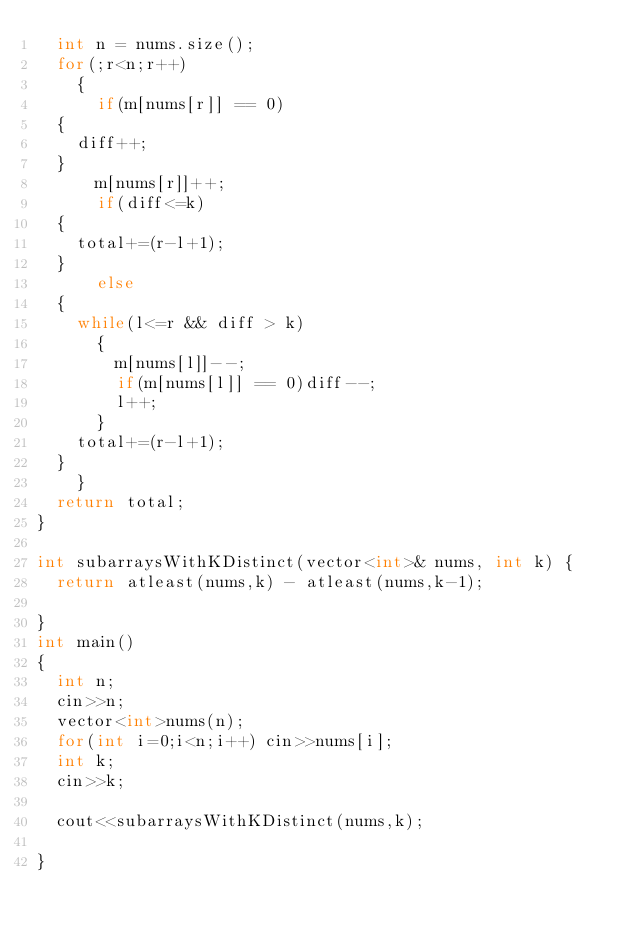<code> <loc_0><loc_0><loc_500><loc_500><_C++_>  int n = nums.size();
  for(;r<n;r++)
    {
      if(m[nums[r]] == 0)
	{
	  diff++;
	}
      m[nums[r]]++;
      if(diff<=k) 
	{
	  total+=(r-l+1);
	}
      else
	{
	  while(l<=r && diff > k)
	    {
	      m[nums[l]]--;
	      if(m[nums[l]] == 0)diff--;
	      l++;
	    }
	  total+=(r-l+1);
	}
    }
  return total;
}

int subarraysWithKDistinct(vector<int>& nums, int k) {
  return atleast(nums,k) - atleast(nums,k-1);
        
}
int main()
{
  int n;
  cin>>n;
  vector<int>nums(n);
  for(int i=0;i<n;i++) cin>>nums[i];
  int k;
  cin>>k;

  cout<<subarraysWithKDistinct(nums,k);
  
}
</code> 